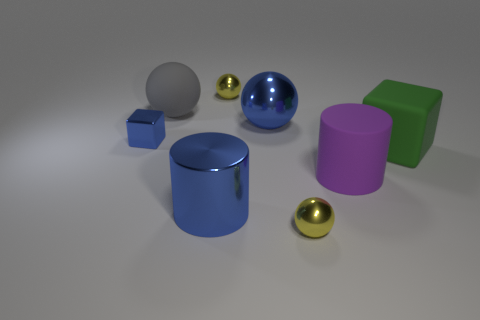Add 1 big blue cylinders. How many objects exist? 9 Subtract all blocks. How many objects are left? 6 Add 8 large gray matte objects. How many large gray matte objects are left? 9 Add 1 big yellow rubber cylinders. How many big yellow rubber cylinders exist? 1 Subtract 0 red blocks. How many objects are left? 8 Subtract all green cubes. Subtract all big green matte blocks. How many objects are left? 6 